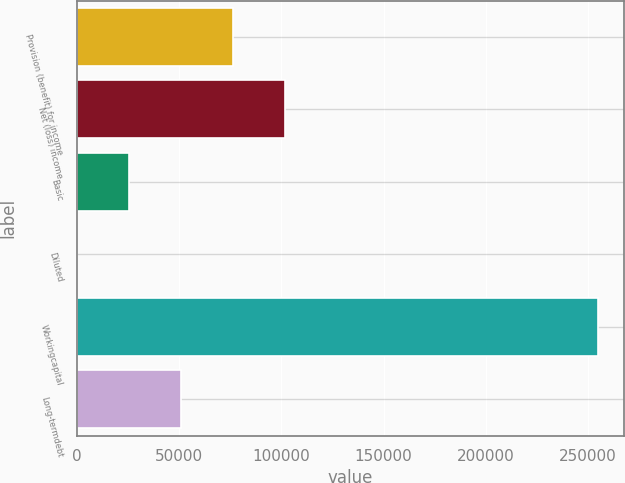Convert chart. <chart><loc_0><loc_0><loc_500><loc_500><bar_chart><fcel>Provision (benefit) for income<fcel>Net (loss) income<fcel>Basic<fcel>Diluted<fcel>Workingcapital<fcel>Long-termdebt<nl><fcel>76488.9<fcel>101985<fcel>25496.6<fcel>0.44<fcel>254962<fcel>50992.8<nl></chart> 